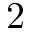Convert formula to latex. <formula><loc_0><loc_0><loc_500><loc_500>2</formula> 